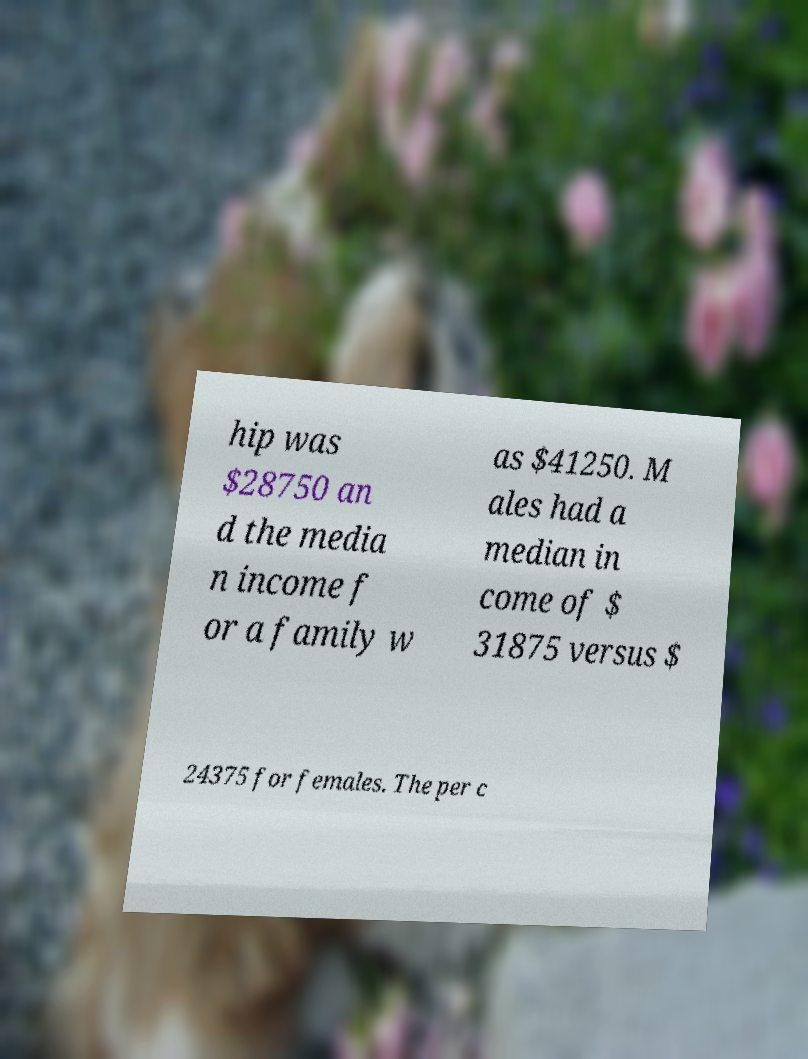Can you accurately transcribe the text from the provided image for me? hip was $28750 an d the media n income f or a family w as $41250. M ales had a median in come of $ 31875 versus $ 24375 for females. The per c 